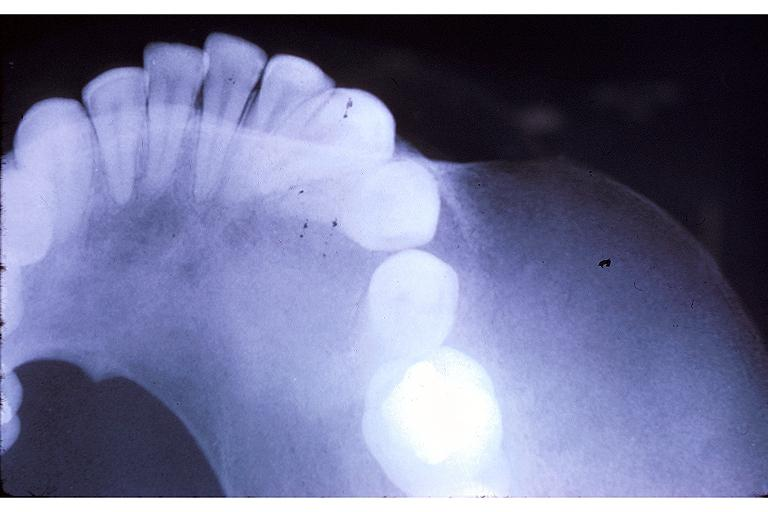what does this image show?
Answer the question using a single word or phrase. Fibrous dysplasia 